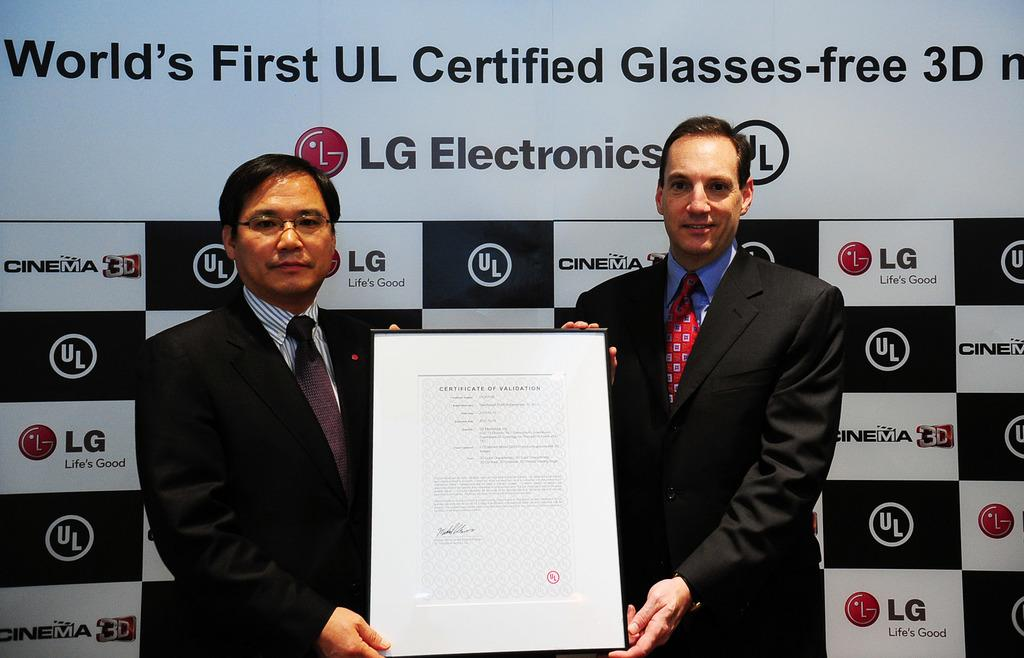How many people are present in the image? There are two people in the image. What are the two people holding in the image? The two people are holding a certificate. What can be seen in the background of the image? There is a board with labels in the background of the image. What type of yam is being exchanged between the two people in the image? There is no yam present in the image, nor is there any indication of an exchange taking place. 